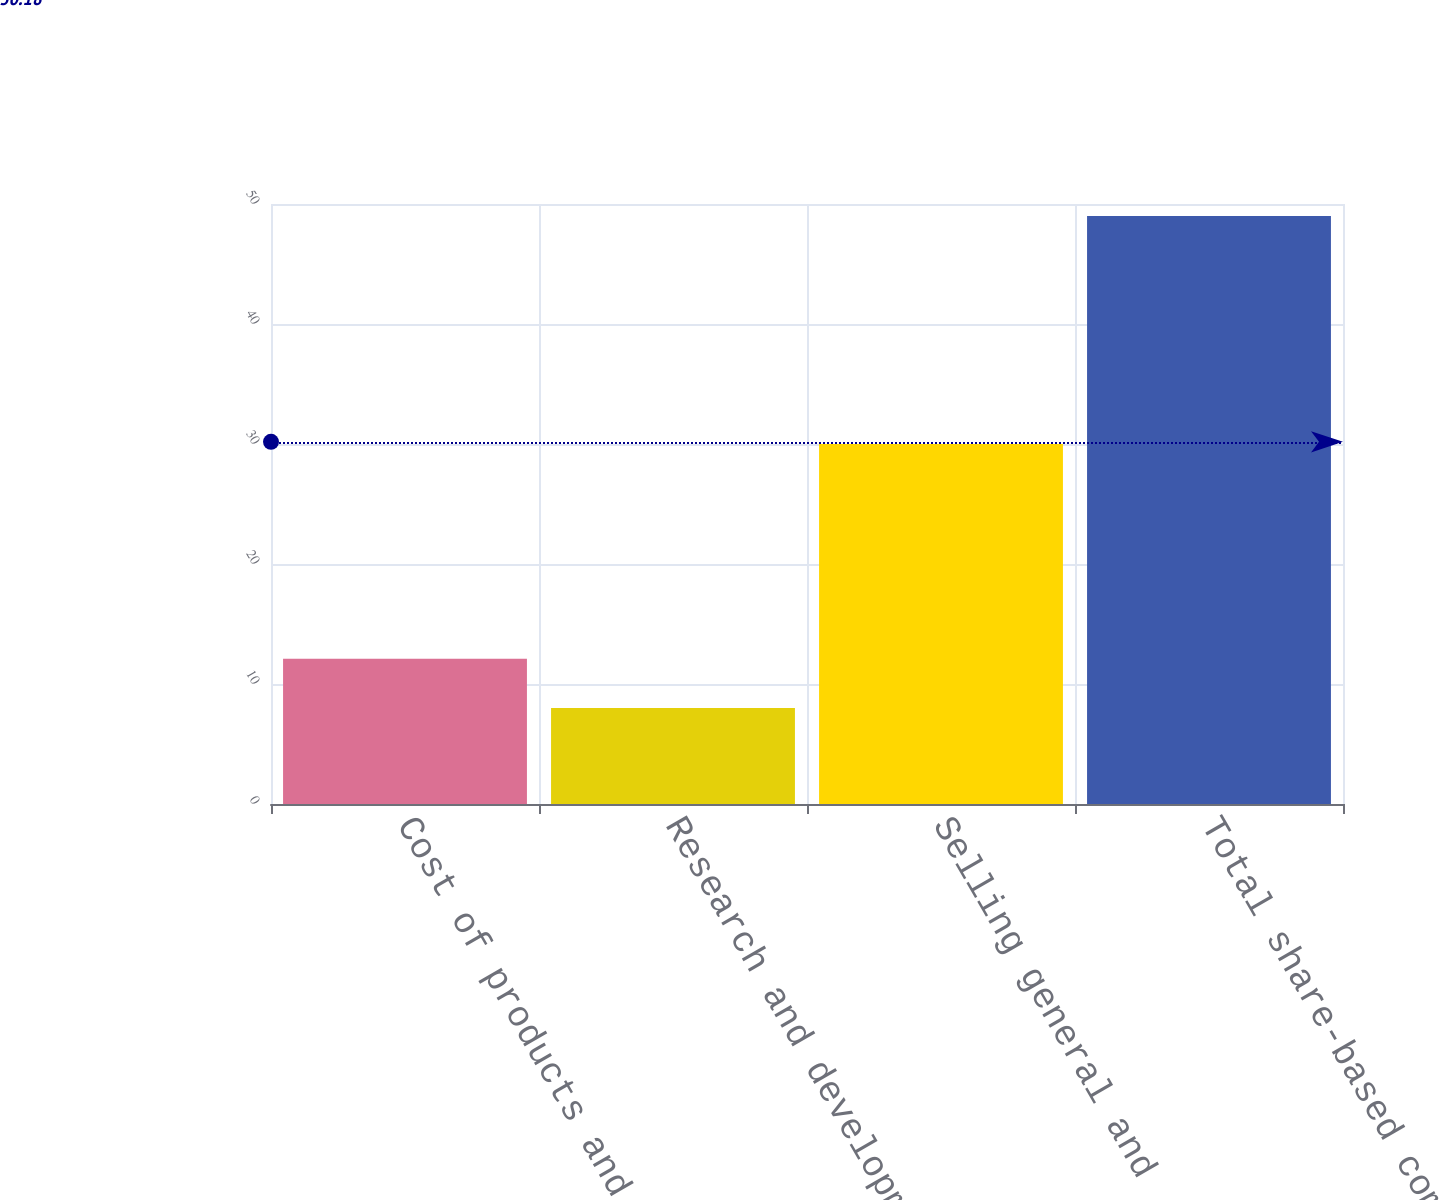Convert chart to OTSL. <chart><loc_0><loc_0><loc_500><loc_500><bar_chart><fcel>Cost of products and services<fcel>Research and development<fcel>Selling general and<fcel>Total share-based compensation<nl><fcel>12.1<fcel>8<fcel>30<fcel>49<nl></chart> 